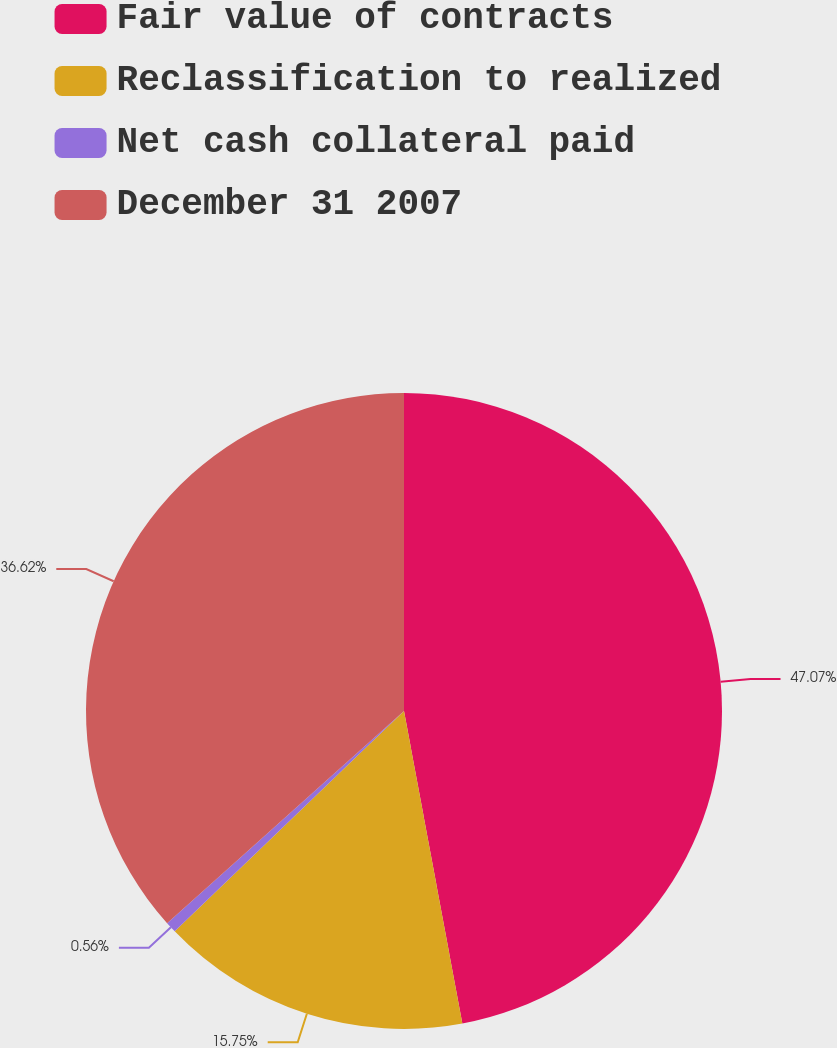<chart> <loc_0><loc_0><loc_500><loc_500><pie_chart><fcel>Fair value of contracts<fcel>Reclassification to realized<fcel>Net cash collateral paid<fcel>December 31 2007<nl><fcel>47.06%<fcel>15.75%<fcel>0.56%<fcel>36.62%<nl></chart> 